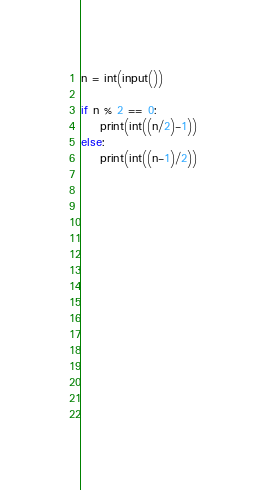Convert code to text. <code><loc_0><loc_0><loc_500><loc_500><_Python_>n = int(input())

if n % 2 == 0:
    print(int((n/2)-1))
else:
    print(int((n-1)/2))




        


    







        

</code> 